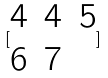Convert formula to latex. <formula><loc_0><loc_0><loc_500><loc_500>[ \begin{matrix} 4 & 4 & 5 \\ 6 & 7 \end{matrix} ]</formula> 